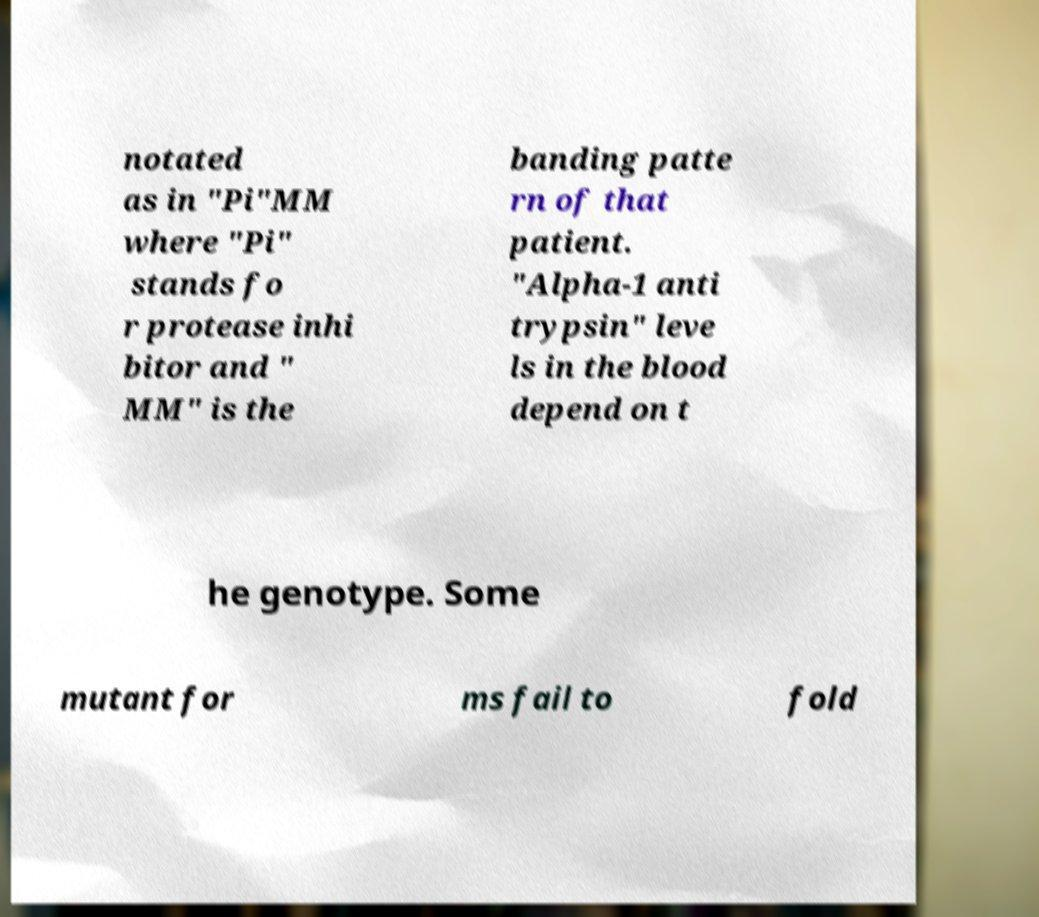Please identify and transcribe the text found in this image. notated as in "Pi"MM where "Pi" stands fo r protease inhi bitor and " MM" is the banding patte rn of that patient. "Alpha-1 anti trypsin" leve ls in the blood depend on t he genotype. Some mutant for ms fail to fold 